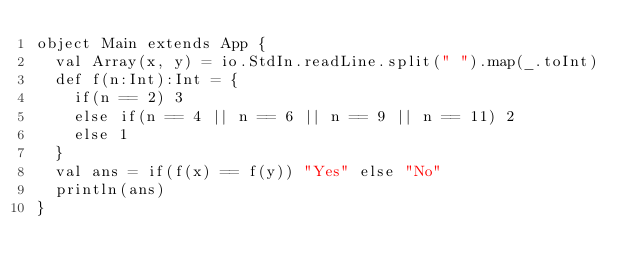Convert code to text. <code><loc_0><loc_0><loc_500><loc_500><_Scala_>object Main extends App {
  val Array(x, y) = io.StdIn.readLine.split(" ").map(_.toInt)
  def f(n:Int):Int = {
    if(n == 2) 3
    else if(n == 4 || n == 6 || n == 9 || n == 11) 2
    else 1
  }
  val ans = if(f(x) == f(y)) "Yes" else "No"
  println(ans)
}</code> 